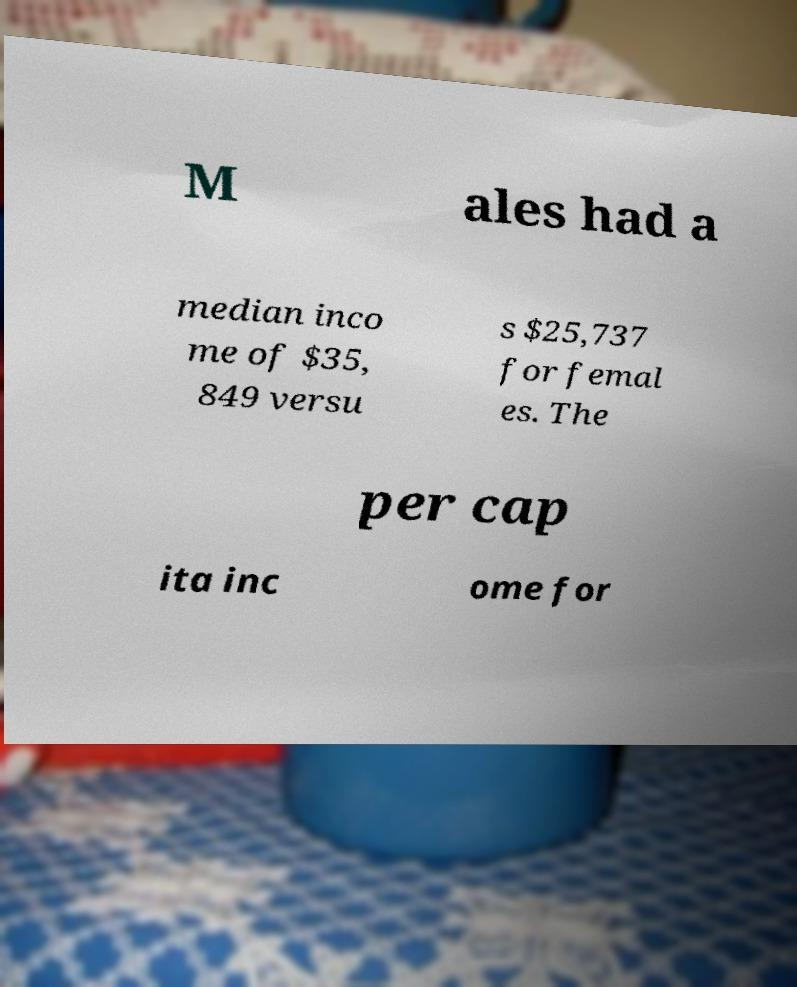Please identify and transcribe the text found in this image. M ales had a median inco me of $35, 849 versu s $25,737 for femal es. The per cap ita inc ome for 